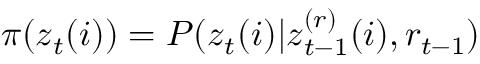<formula> <loc_0><loc_0><loc_500><loc_500>\pi ( z _ { t } ( i ) ) = P ( z _ { t } ( i ) | z _ { t - 1 } ^ { ( r ) } ( i ) , r _ { t - 1 } )</formula> 